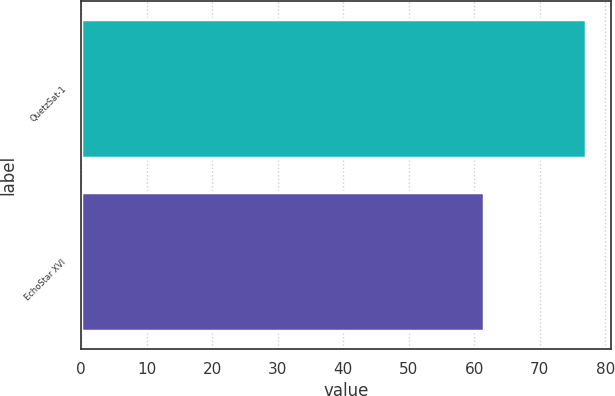Convert chart. <chart><loc_0><loc_0><loc_500><loc_500><bar_chart><fcel>QuetzSat-1<fcel>EchoStar XVI<nl><fcel>77<fcel>61.5<nl></chart> 